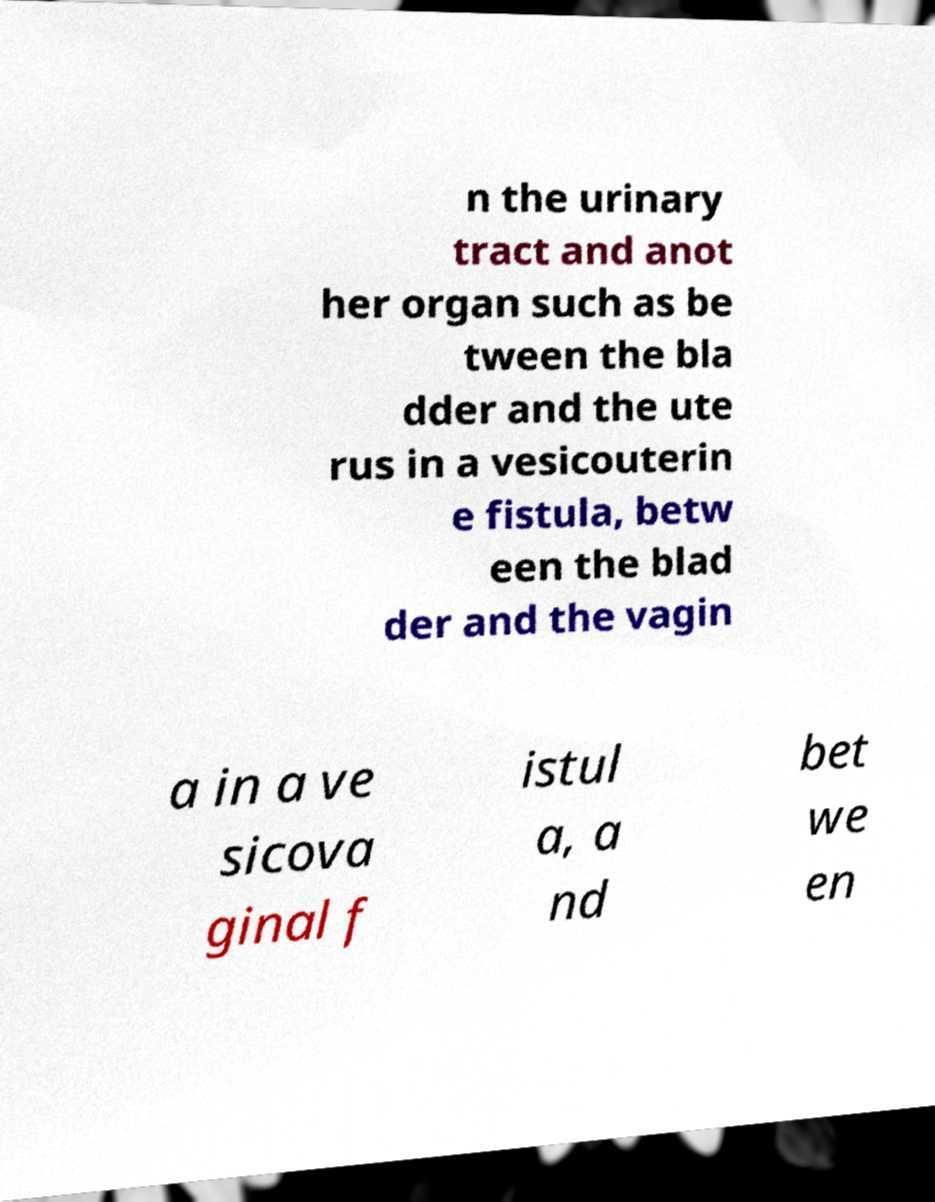Please identify and transcribe the text found in this image. n the urinary tract and anot her organ such as be tween the bla dder and the ute rus in a vesicouterin e fistula, betw een the blad der and the vagin a in a ve sicova ginal f istul a, a nd bet we en 